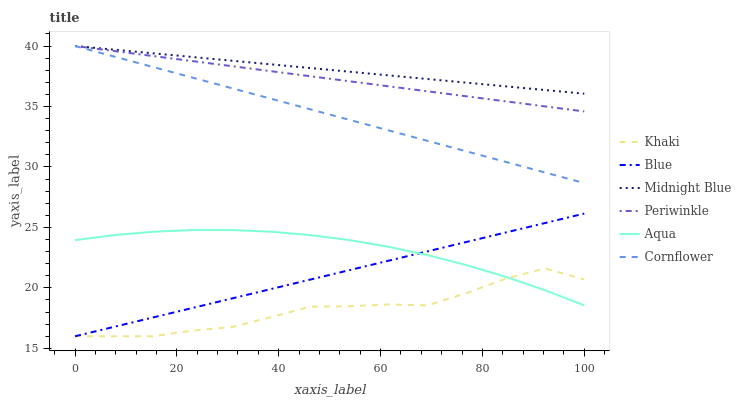Does Khaki have the minimum area under the curve?
Answer yes or no. Yes. Does Midnight Blue have the maximum area under the curve?
Answer yes or no. Yes. Does Cornflower have the minimum area under the curve?
Answer yes or no. No. Does Cornflower have the maximum area under the curve?
Answer yes or no. No. Is Midnight Blue the smoothest?
Answer yes or no. Yes. Is Khaki the roughest?
Answer yes or no. Yes. Is Cornflower the smoothest?
Answer yes or no. No. Is Cornflower the roughest?
Answer yes or no. No. Does Cornflower have the lowest value?
Answer yes or no. No. Does Periwinkle have the highest value?
Answer yes or no. Yes. Does Khaki have the highest value?
Answer yes or no. No. Is Khaki less than Midnight Blue?
Answer yes or no. Yes. Is Midnight Blue greater than Aqua?
Answer yes or no. Yes. Does Cornflower intersect Midnight Blue?
Answer yes or no. Yes. Is Cornflower less than Midnight Blue?
Answer yes or no. No. Is Cornflower greater than Midnight Blue?
Answer yes or no. No. Does Khaki intersect Midnight Blue?
Answer yes or no. No. 